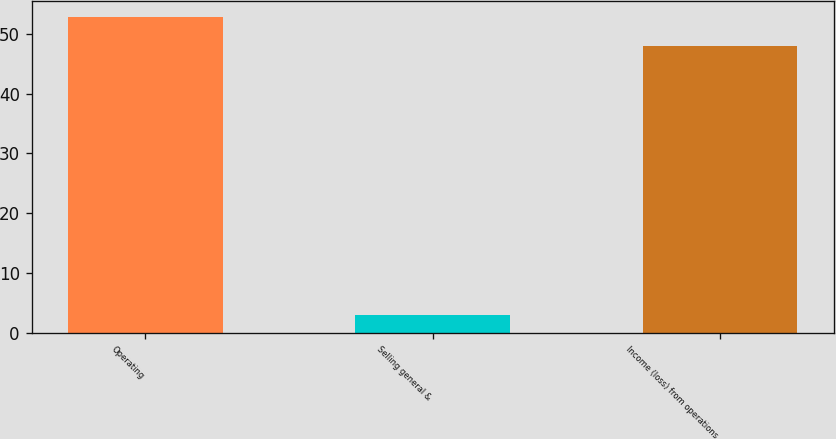<chart> <loc_0><loc_0><loc_500><loc_500><bar_chart><fcel>Operating<fcel>Selling general &<fcel>Income (loss) from operations<nl><fcel>52.8<fcel>3<fcel>48<nl></chart> 